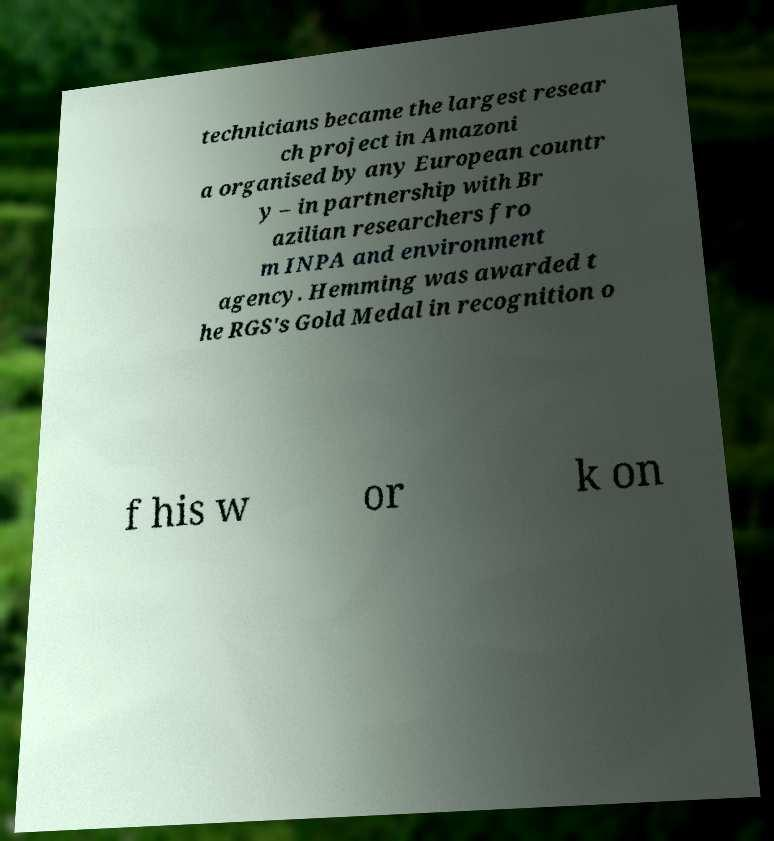I need the written content from this picture converted into text. Can you do that? technicians became the largest resear ch project in Amazoni a organised by any European countr y – in partnership with Br azilian researchers fro m INPA and environment agency. Hemming was awarded t he RGS's Gold Medal in recognition o f his w or k on 